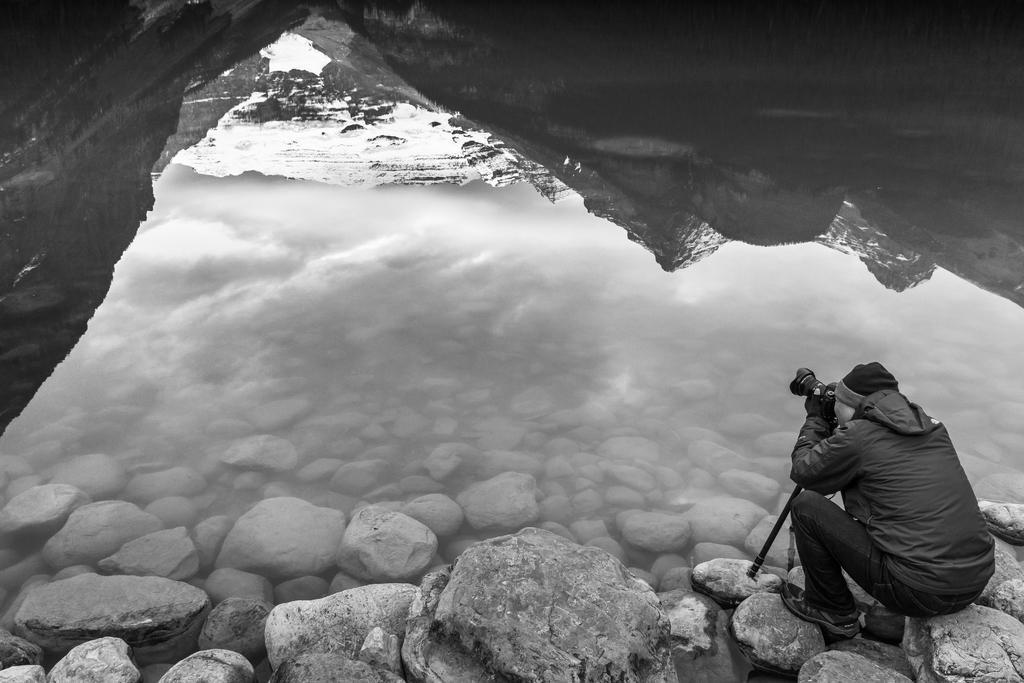Can you describe this image briefly? In this image I can see number of stones, mountains, a person and a camera. I can see this person is wearing jeans, jacket and a cap. I can see this image is black and white in colour. 